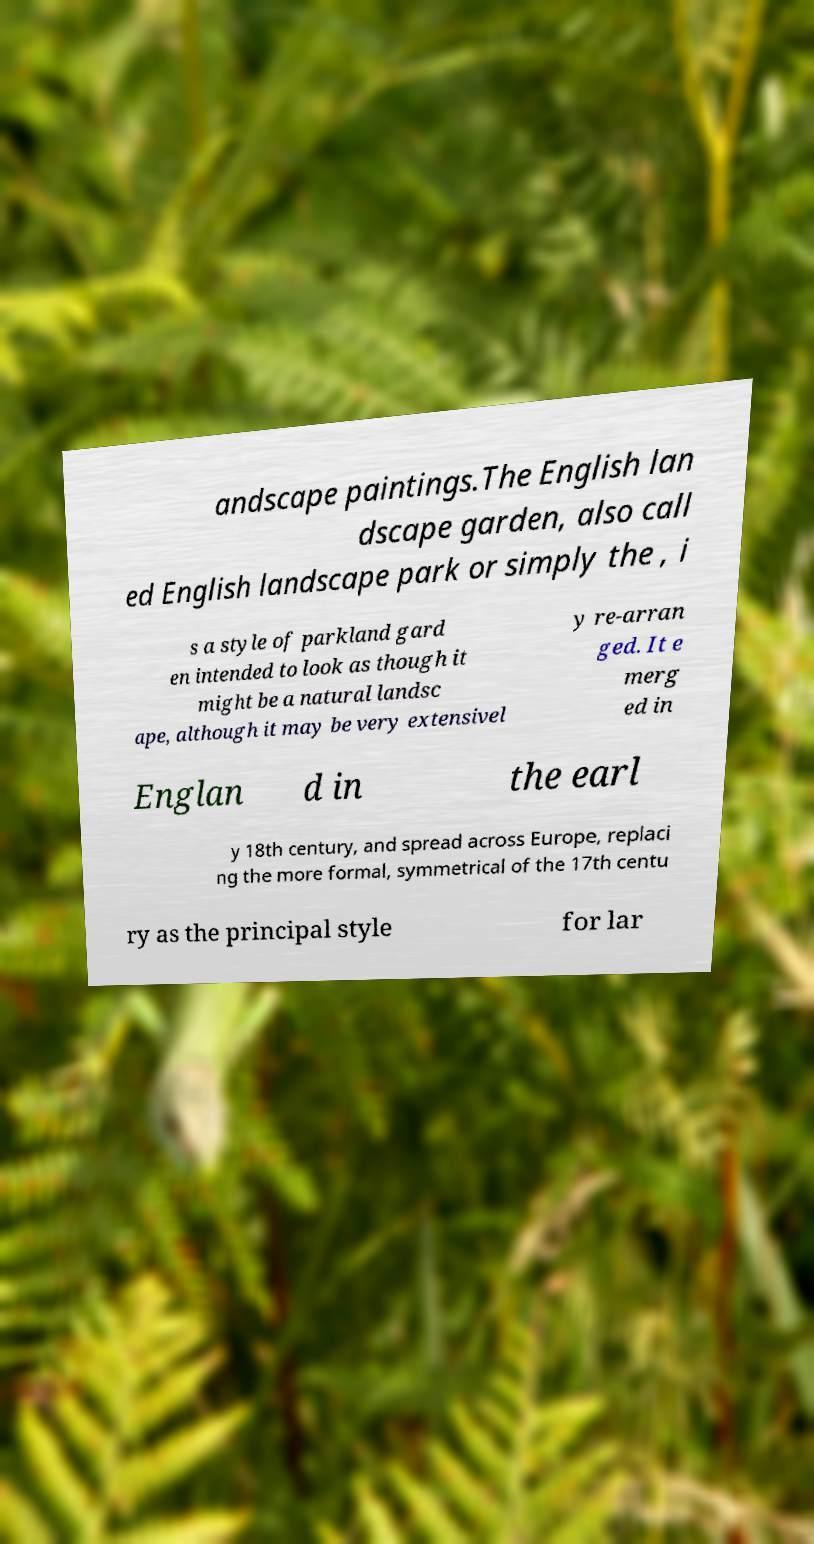There's text embedded in this image that I need extracted. Can you transcribe it verbatim? andscape paintings.The English lan dscape garden, also call ed English landscape park or simply the , i s a style of parkland gard en intended to look as though it might be a natural landsc ape, although it may be very extensivel y re-arran ged. It e merg ed in Englan d in the earl y 18th century, and spread across Europe, replaci ng the more formal, symmetrical of the 17th centu ry as the principal style for lar 